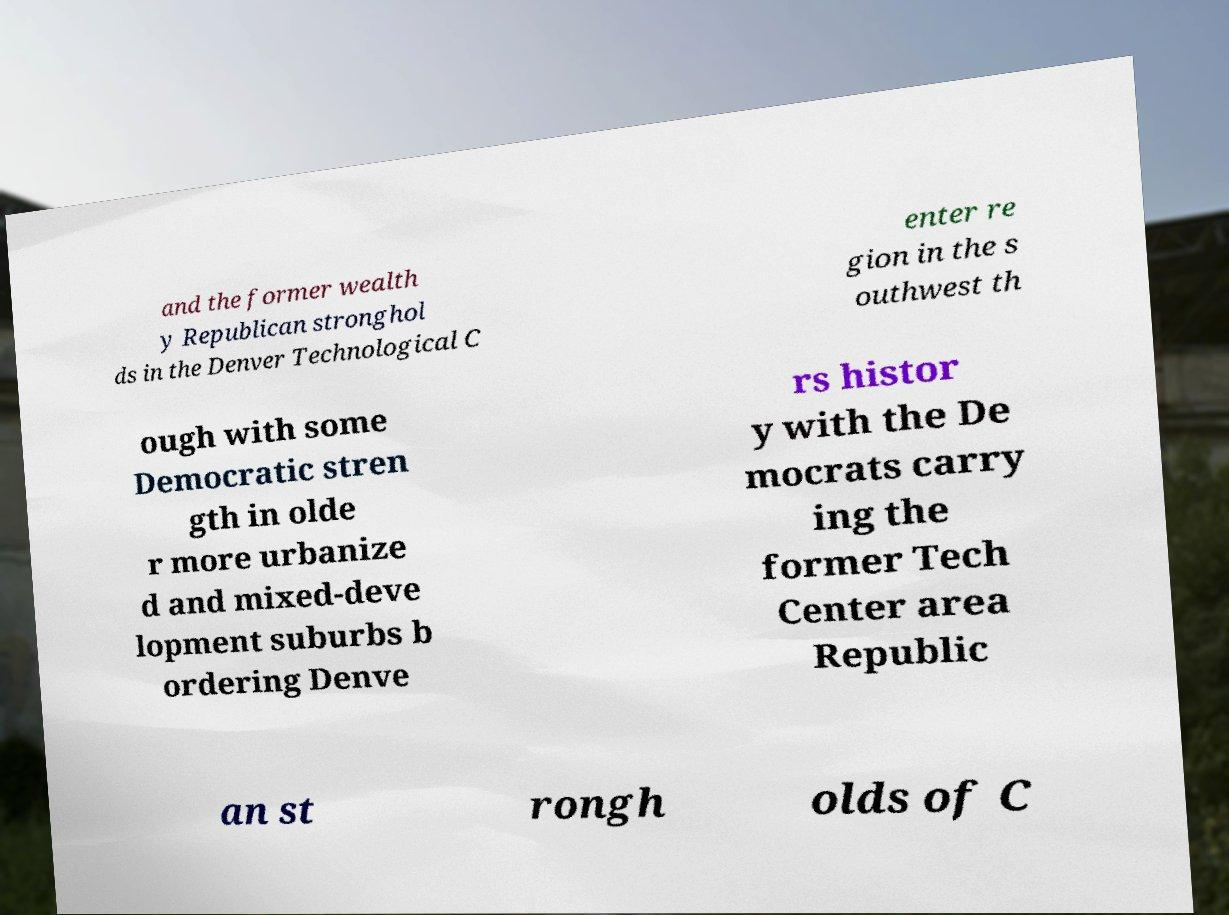I need the written content from this picture converted into text. Can you do that? and the former wealth y Republican stronghol ds in the Denver Technological C enter re gion in the s outhwest th ough with some Democratic stren gth in olde r more urbanize d and mixed-deve lopment suburbs b ordering Denve rs histor y with the De mocrats carry ing the former Tech Center area Republic an st rongh olds of C 